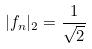<formula> <loc_0><loc_0><loc_500><loc_500>| f _ { n } | _ { 2 } = \frac { 1 } { \sqrt { 2 } }</formula> 